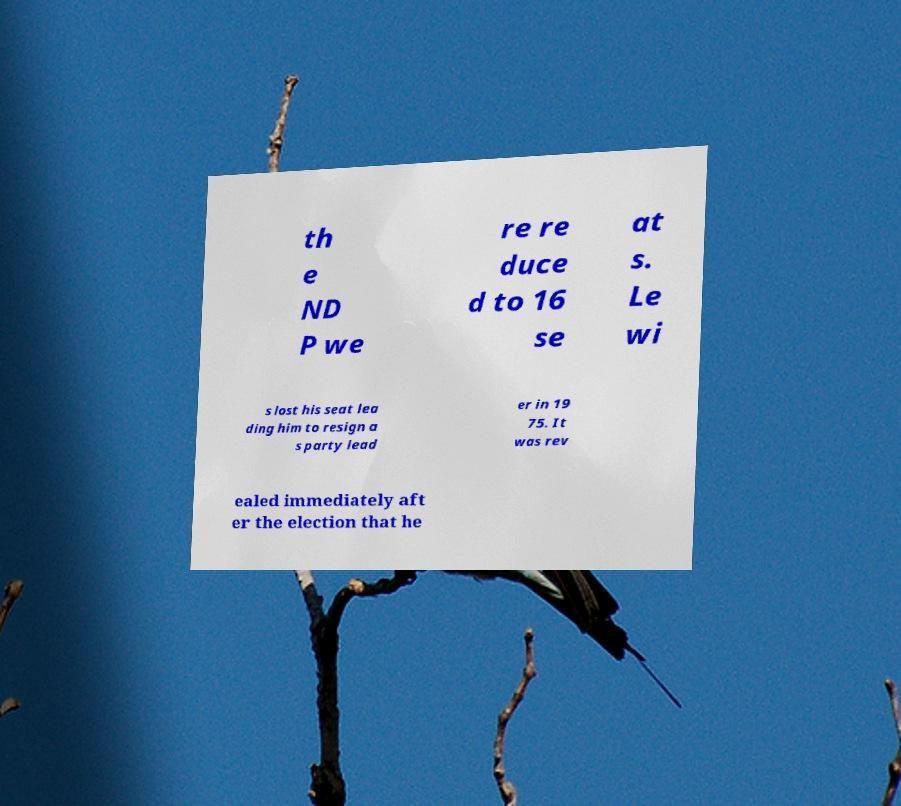Can you accurately transcribe the text from the provided image for me? th e ND P we re re duce d to 16 se at s. Le wi s lost his seat lea ding him to resign a s party lead er in 19 75. It was rev ealed immediately aft er the election that he 